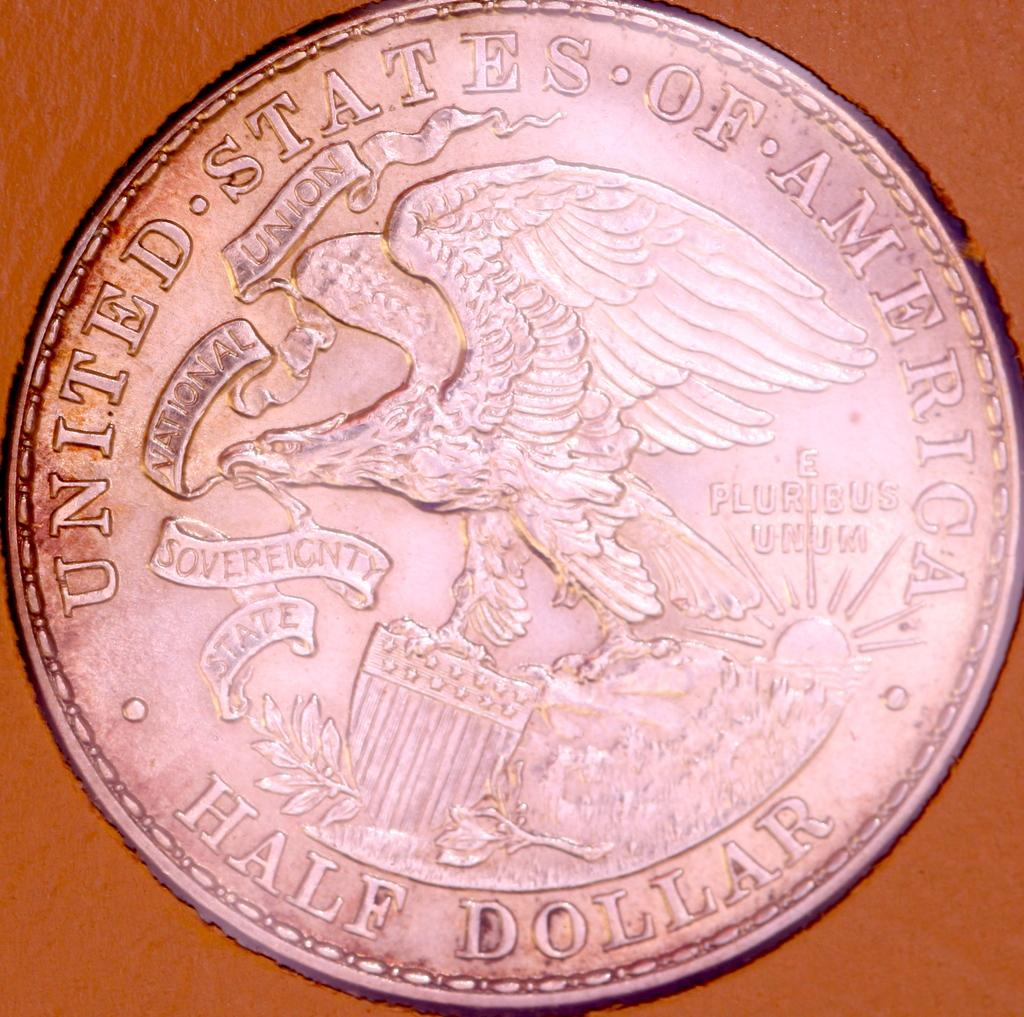<image>
Summarize the visual content of the image. a United States of America half dollar coin 